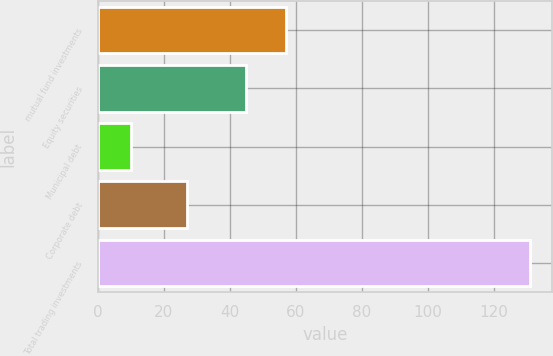<chart> <loc_0><loc_0><loc_500><loc_500><bar_chart><fcel>mutual fund investments<fcel>Equity securities<fcel>Municipal debt<fcel>Corporate debt<fcel>Total trading investments<nl><fcel>57.1<fcel>45<fcel>10<fcel>27<fcel>131<nl></chart> 